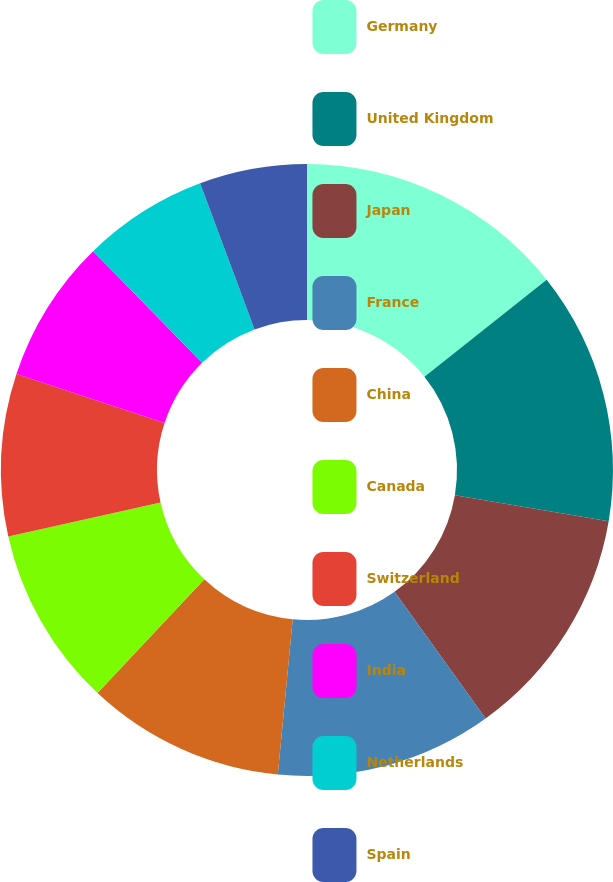Convert chart. <chart><loc_0><loc_0><loc_500><loc_500><pie_chart><fcel>Germany<fcel>United Kingdom<fcel>Japan<fcel>France<fcel>China<fcel>Canada<fcel>Switzerland<fcel>India<fcel>Netherlands<fcel>Spain<nl><fcel>14.32%<fcel>13.36%<fcel>12.4%<fcel>11.44%<fcel>10.48%<fcel>9.52%<fcel>8.56%<fcel>7.6%<fcel>6.64%<fcel>5.68%<nl></chart> 